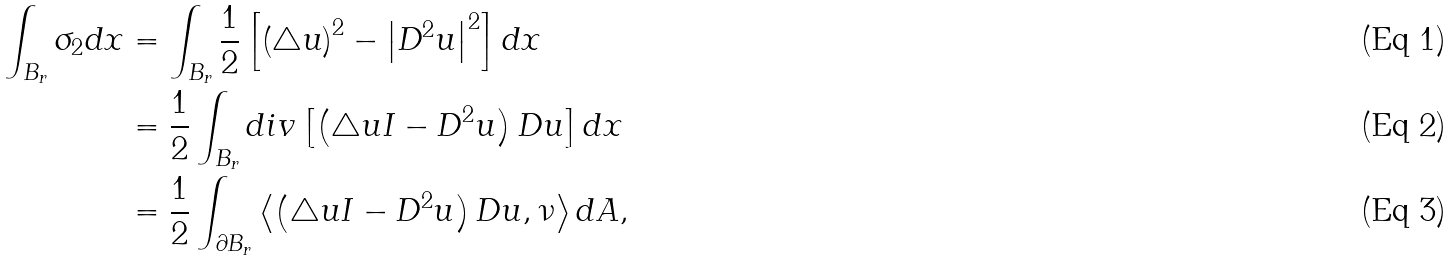Convert formula to latex. <formula><loc_0><loc_0><loc_500><loc_500>\int _ { B _ { r } } \sigma _ { 2 } d x & = \int _ { B _ { r } } \frac { 1 } { 2 } \left [ \left ( \bigtriangleup u \right ) ^ { 2 } - \left | D ^ { 2 } u \right | ^ { 2 } \right ] d x \\ & = \frac { 1 } { 2 } \int _ { B _ { r } } d i v \left [ \left ( \bigtriangleup u I - D ^ { 2 } u \right ) D u \right ] d x \\ & = \frac { 1 } { 2 } \int _ { \partial B _ { r } } \left \langle \left ( \bigtriangleup u I - D ^ { 2 } u \right ) D u , \nu \right \rangle d A ,</formula> 